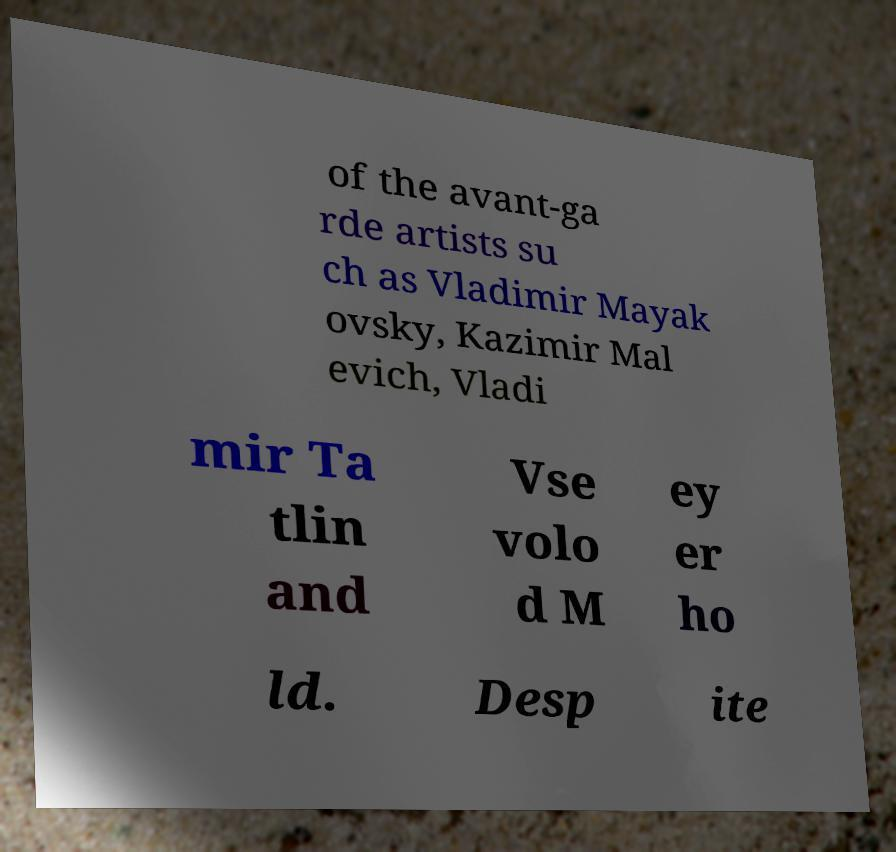For documentation purposes, I need the text within this image transcribed. Could you provide that? of the avant-ga rde artists su ch as Vladimir Mayak ovsky, Kazimir Mal evich, Vladi mir Ta tlin and Vse volo d M ey er ho ld. Desp ite 